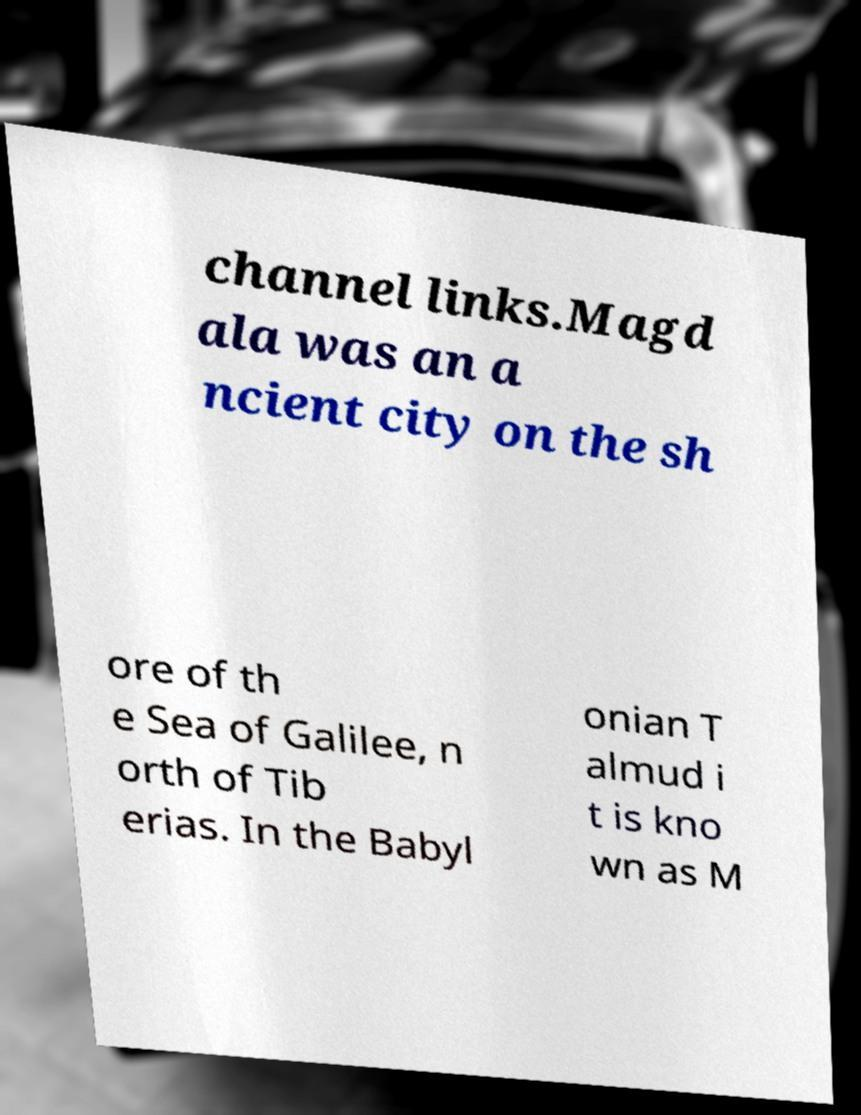I need the written content from this picture converted into text. Can you do that? channel links.Magd ala was an a ncient city on the sh ore of th e Sea of Galilee, n orth of Tib erias. In the Babyl onian T almud i t is kno wn as M 